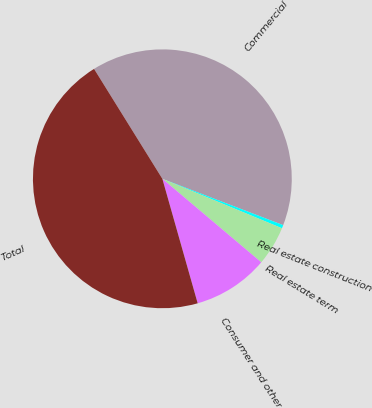<chart> <loc_0><loc_0><loc_500><loc_500><pie_chart><fcel>Commercial<fcel>Real estate construction<fcel>Real estate term<fcel>Consumer and other<fcel>Total<nl><fcel>39.68%<fcel>0.41%<fcel>4.92%<fcel>9.44%<fcel>45.55%<nl></chart> 